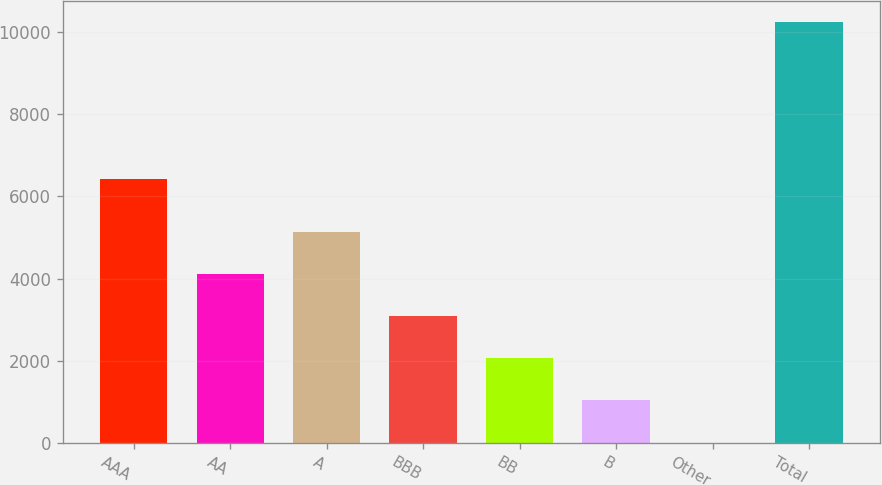Convert chart. <chart><loc_0><loc_0><loc_500><loc_500><bar_chart><fcel>AAA<fcel>AA<fcel>A<fcel>BBB<fcel>BB<fcel>B<fcel>Other<fcel>Total<nl><fcel>6422<fcel>4101<fcel>5125.1<fcel>3076.9<fcel>2052.8<fcel>1028.7<fcel>4.6<fcel>10245.6<nl></chart> 